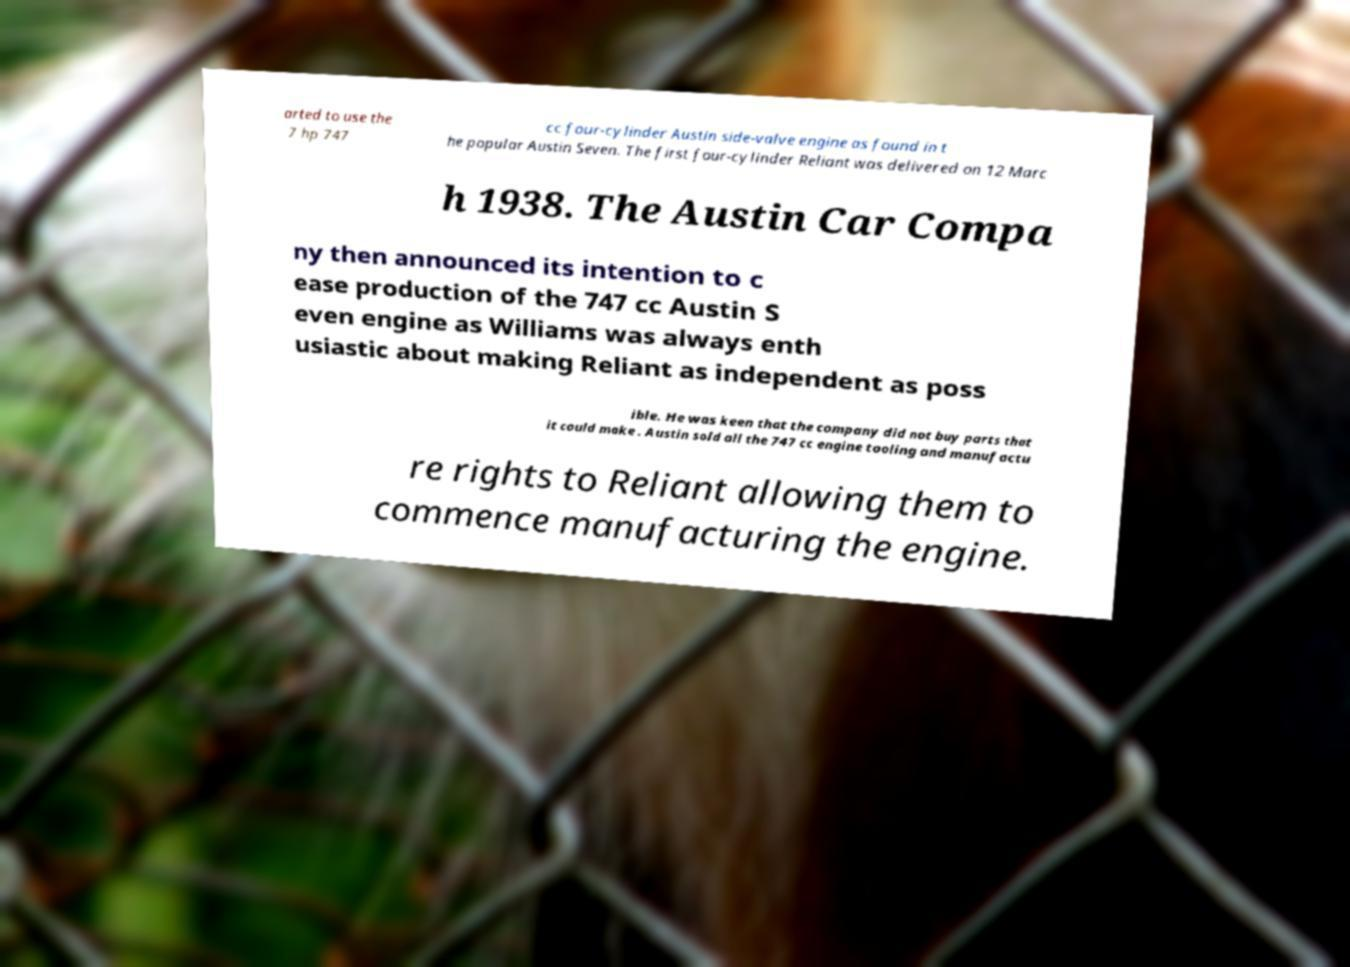Please read and relay the text visible in this image. What does it say? arted to use the 7 hp 747 cc four-cylinder Austin side-valve engine as found in t he popular Austin Seven. The first four-cylinder Reliant was delivered on 12 Marc h 1938. The Austin Car Compa ny then announced its intention to c ease production of the 747 cc Austin S even engine as Williams was always enth usiastic about making Reliant as independent as poss ible. He was keen that the company did not buy parts that it could make . Austin sold all the 747 cc engine tooling and manufactu re rights to Reliant allowing them to commence manufacturing the engine. 